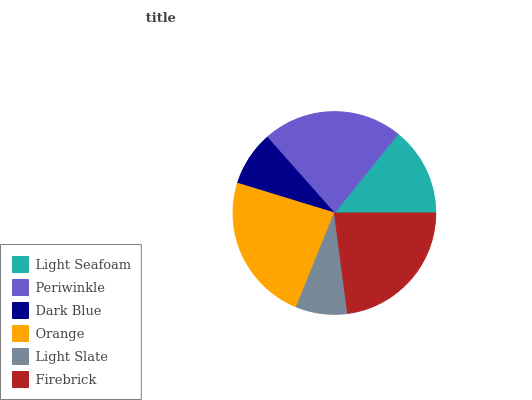Is Light Slate the minimum?
Answer yes or no. Yes. Is Orange the maximum?
Answer yes or no. Yes. Is Periwinkle the minimum?
Answer yes or no. No. Is Periwinkle the maximum?
Answer yes or no. No. Is Periwinkle greater than Light Seafoam?
Answer yes or no. Yes. Is Light Seafoam less than Periwinkle?
Answer yes or no. Yes. Is Light Seafoam greater than Periwinkle?
Answer yes or no. No. Is Periwinkle less than Light Seafoam?
Answer yes or no. No. Is Periwinkle the high median?
Answer yes or no. Yes. Is Light Seafoam the low median?
Answer yes or no. Yes. Is Light Seafoam the high median?
Answer yes or no. No. Is Orange the low median?
Answer yes or no. No. 